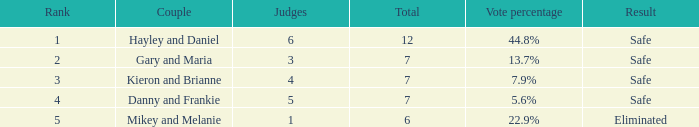How many adjudicators were there for the eliminated duo? 1.0. 